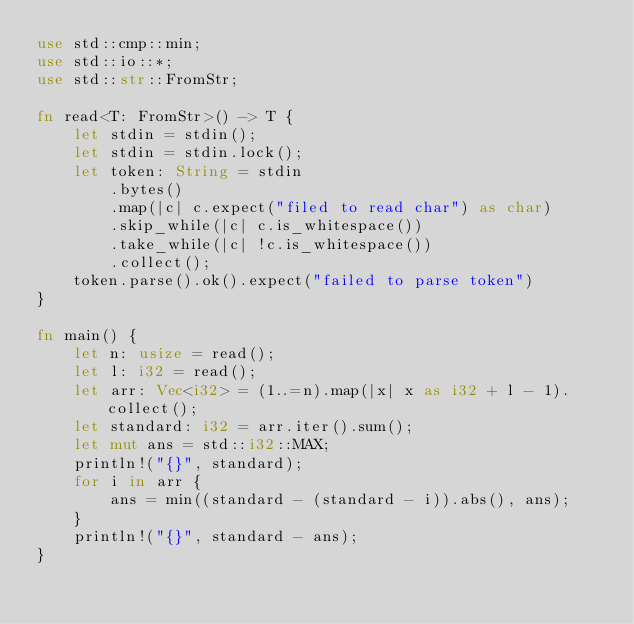Convert code to text. <code><loc_0><loc_0><loc_500><loc_500><_Rust_>use std::cmp::min;
use std::io::*;
use std::str::FromStr;

fn read<T: FromStr>() -> T {
    let stdin = stdin();
    let stdin = stdin.lock();
    let token: String = stdin
        .bytes()
        .map(|c| c.expect("filed to read char") as char)
        .skip_while(|c| c.is_whitespace())
        .take_while(|c| !c.is_whitespace())
        .collect();
    token.parse().ok().expect("failed to parse token")
}

fn main() {
    let n: usize = read();
    let l: i32 = read();
    let arr: Vec<i32> = (1..=n).map(|x| x as i32 + l - 1).collect();
    let standard: i32 = arr.iter().sum();
    let mut ans = std::i32::MAX;
    println!("{}", standard);
    for i in arr {
        ans = min((standard - (standard - i)).abs(), ans);
    }
    println!("{}", standard - ans);
}
</code> 